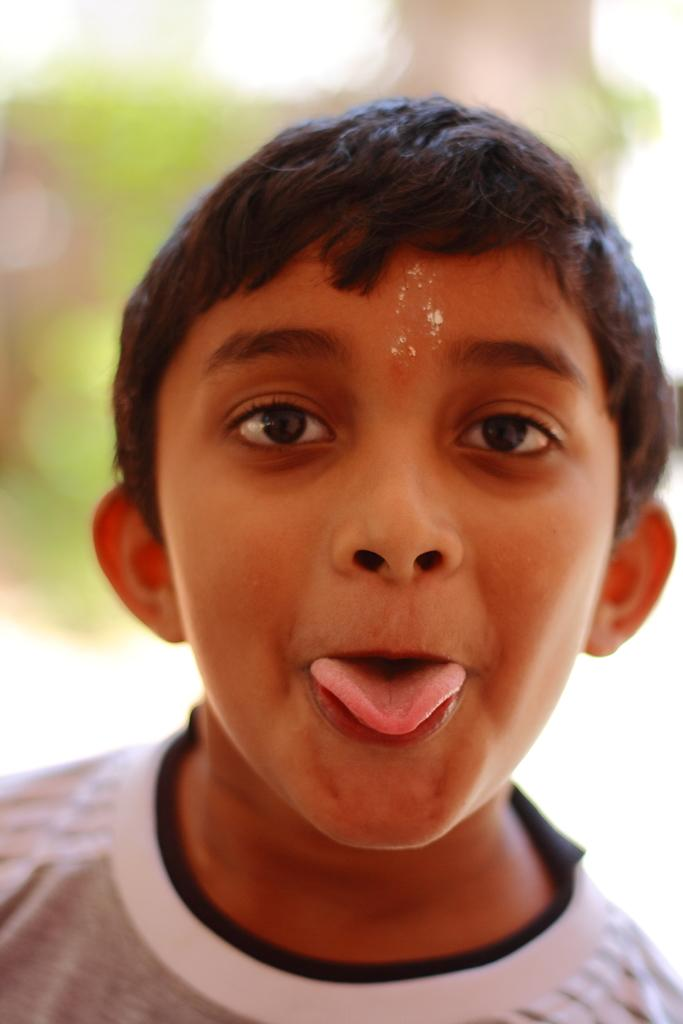What is the main subject of the image? There is a boy in the image. Can you describe the background of the image? The background of the image is blurred. What type of wood is the boy holding in the image? There is no wood present in the image; the boy is not holding any object. 